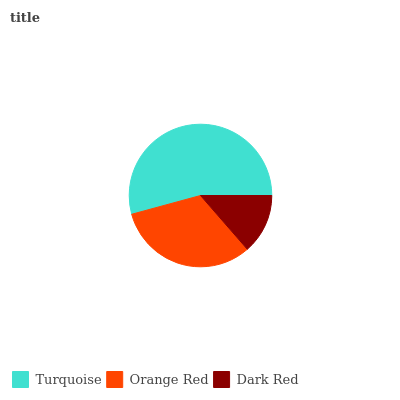Is Dark Red the minimum?
Answer yes or no. Yes. Is Turquoise the maximum?
Answer yes or no. Yes. Is Orange Red the minimum?
Answer yes or no. No. Is Orange Red the maximum?
Answer yes or no. No. Is Turquoise greater than Orange Red?
Answer yes or no. Yes. Is Orange Red less than Turquoise?
Answer yes or no. Yes. Is Orange Red greater than Turquoise?
Answer yes or no. No. Is Turquoise less than Orange Red?
Answer yes or no. No. Is Orange Red the high median?
Answer yes or no. Yes. Is Orange Red the low median?
Answer yes or no. Yes. Is Turquoise the high median?
Answer yes or no. No. Is Turquoise the low median?
Answer yes or no. No. 